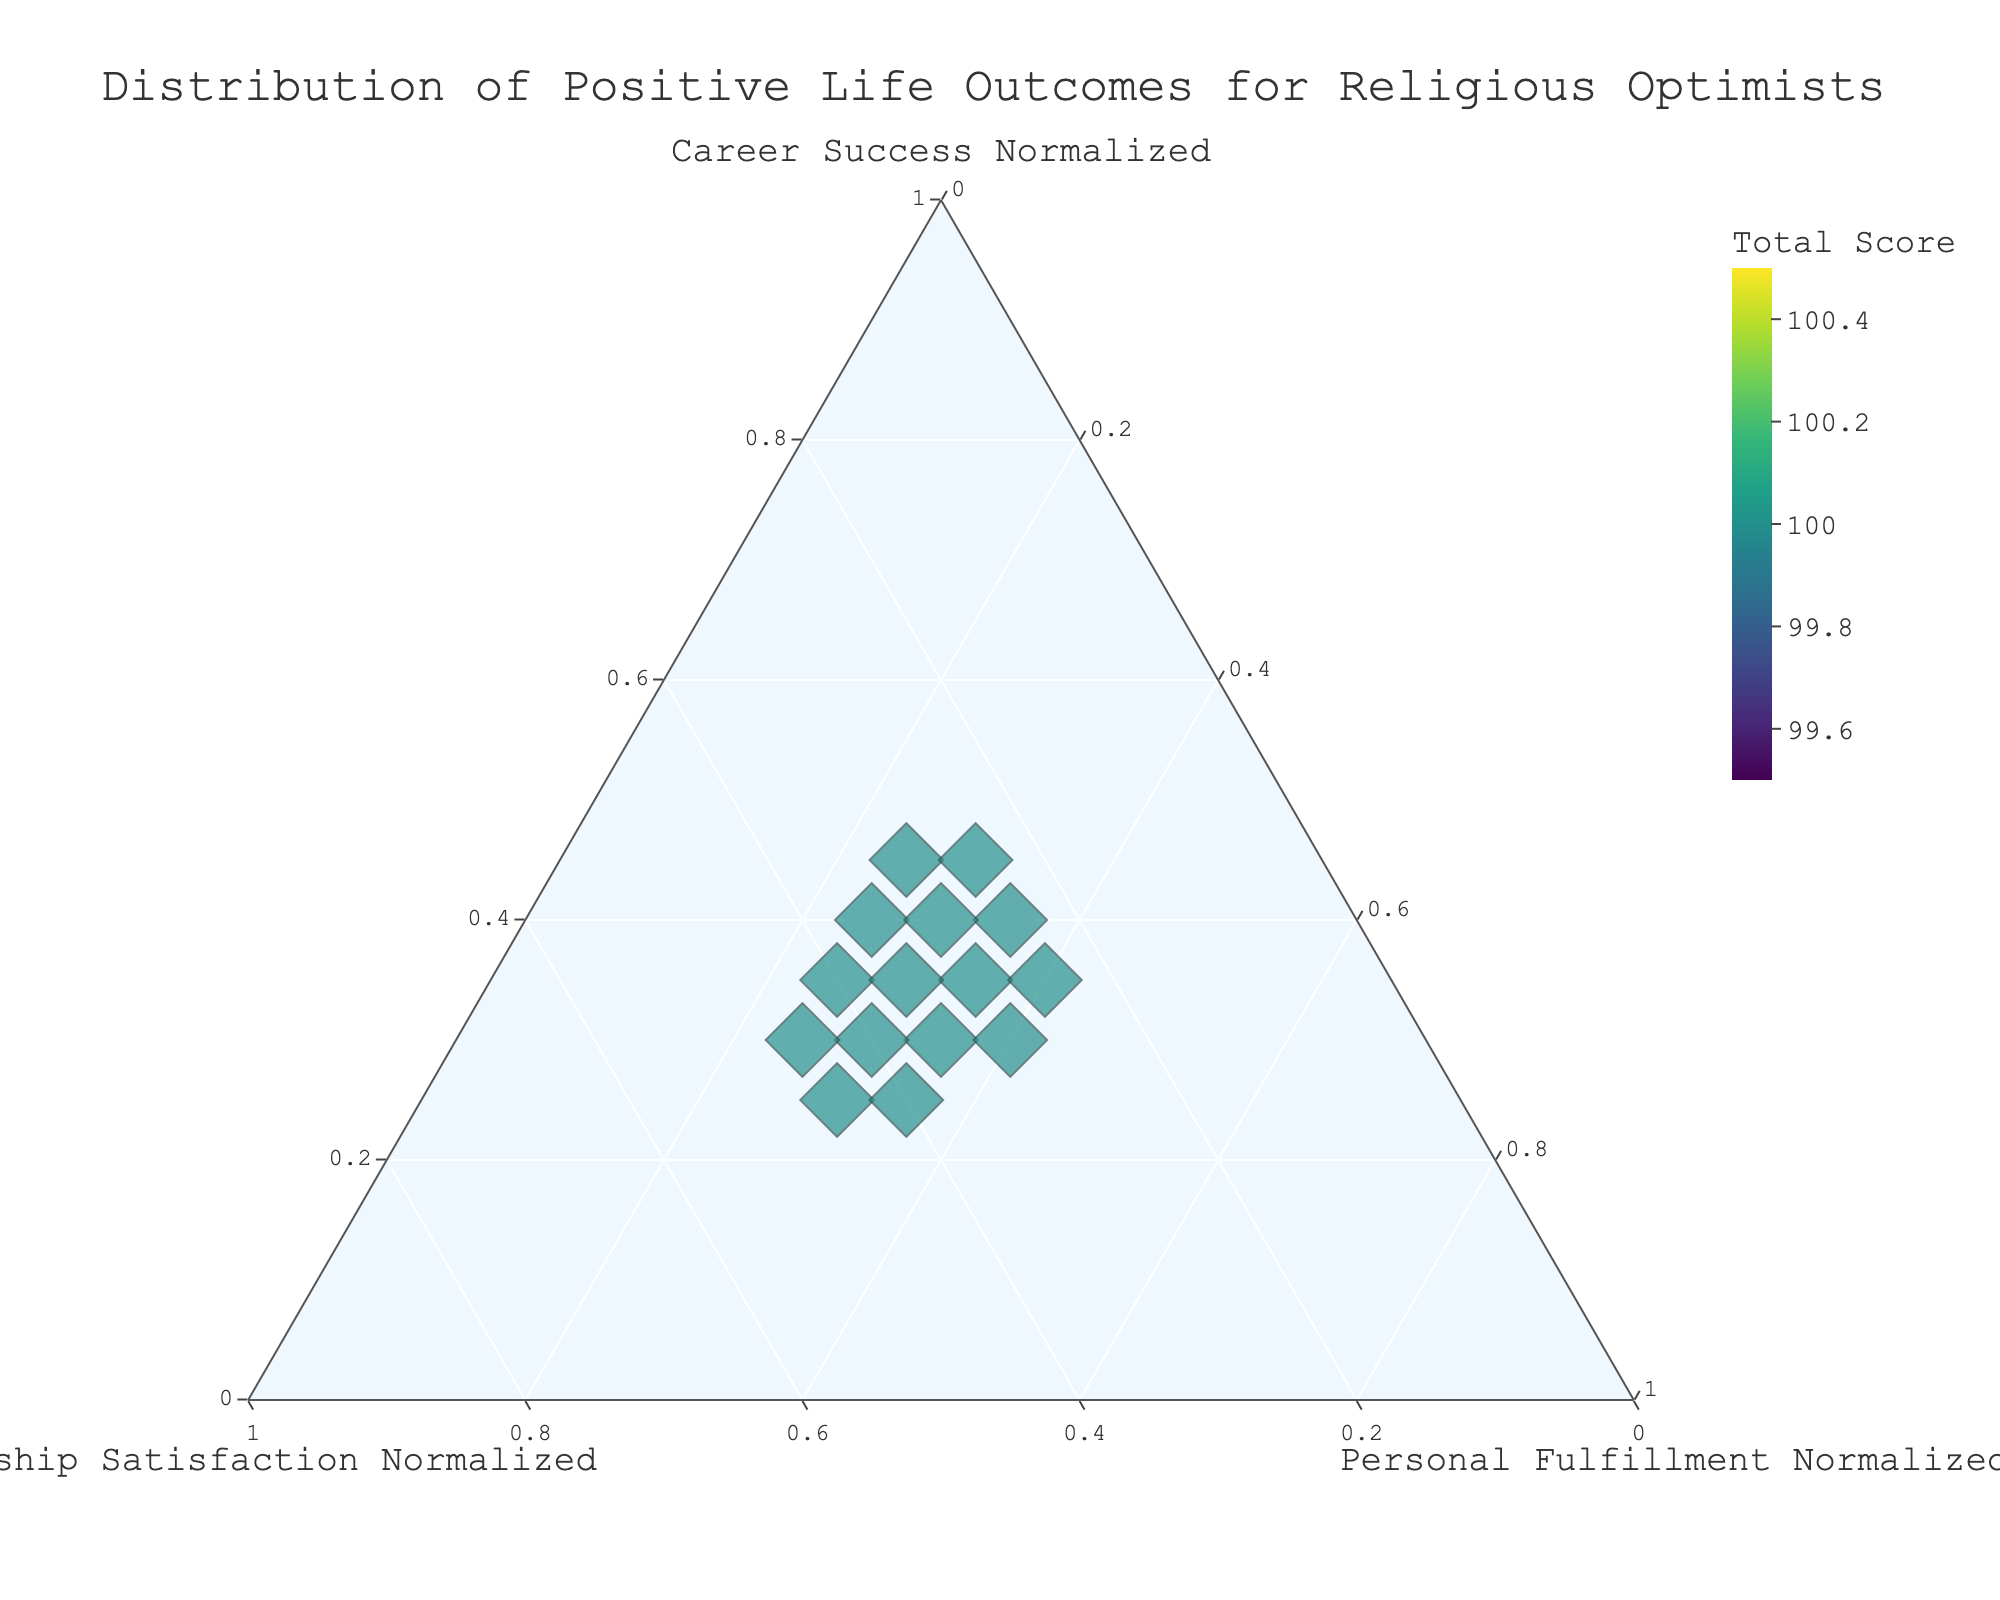How many data points are displayed in the ternary plot? To determine the number of data points, count the individual markers in the plot. Each marker represents a person.
Answer: 15 What is the title of the ternary plot? The title is typically displayed at the top of the plot. Look for the largest text that describes the overall content of the plot.
Answer: Distribution of Positive Life Outcomes for Religious Optimists Which individual has the highest total score? The size and color of the markers can indicate the total score. Larger and darker-colored markers usually represent higher total scores. John Smith has the largest and darkest-colored marker.
Answer: John Smith What is the combination of normalized outcomes for Laura Nguyen? Hover over or reference the plot near her marker to read off the normalized values for Career Success, Relationship Satisfaction, and Personal Fulfillment.
Answer: 25%, 40%, 35% Who has the highest Relationship Satisfaction normalized value? Compare the positions along the Relationship Satisfaction axis. William Jackson is the closest to the vertex representing Relationship Satisfaction.
Answer: William Jackson Among John Smith, Emily Davis, and David Wilson, who has the lowest Career Success normalized value? Check their positions along the Career Success axis and identify the one furthest from the Career Success vertex. David Wilson is furthest from the Career Success axis.
Answer: David Wilson What is the relationship between Career Success and Total Score according to the plot? Observe whether there is a trend between the data points' vertical position (Career Success) and the color and size representing the Total Score. Typically, higher total scores, indicated by larger, darker markers, are more towards higher normalized Career Success.
Answer: Positive correlation Which group of individuals is clustered near 30% Personal Fulfillment normalized value? Check the data points around the Personal Fulfillment vertex and identify those centered at 30%. Rachel Anderson, James Sullivan, and Jessica Thompson cluster around this value.
Answer: Rachel Anderson, James Sullivan, Jessica Thompson Is there any individual whose data point is exactly centered in the plot? Locate any marker equidistant from the three vertices, meaning they have equal percentages for Career Success, Relationship Satisfaction, and Personal Fulfillment. None of the markers appear equidistant from the vertices; hence, no exact center data point exists.
Answer: No How does the spread of Personalized Fulfillment values compare visually to other axes? Compare the dispersion of data points along the Personal Fulfillment vertex to the dispersions along Career Success and Relationship Satisfaction vertices. Personal Fulfillment has a more uniform spread compared to the more varied distributions on the other axes.
Answer: Uniform spread 